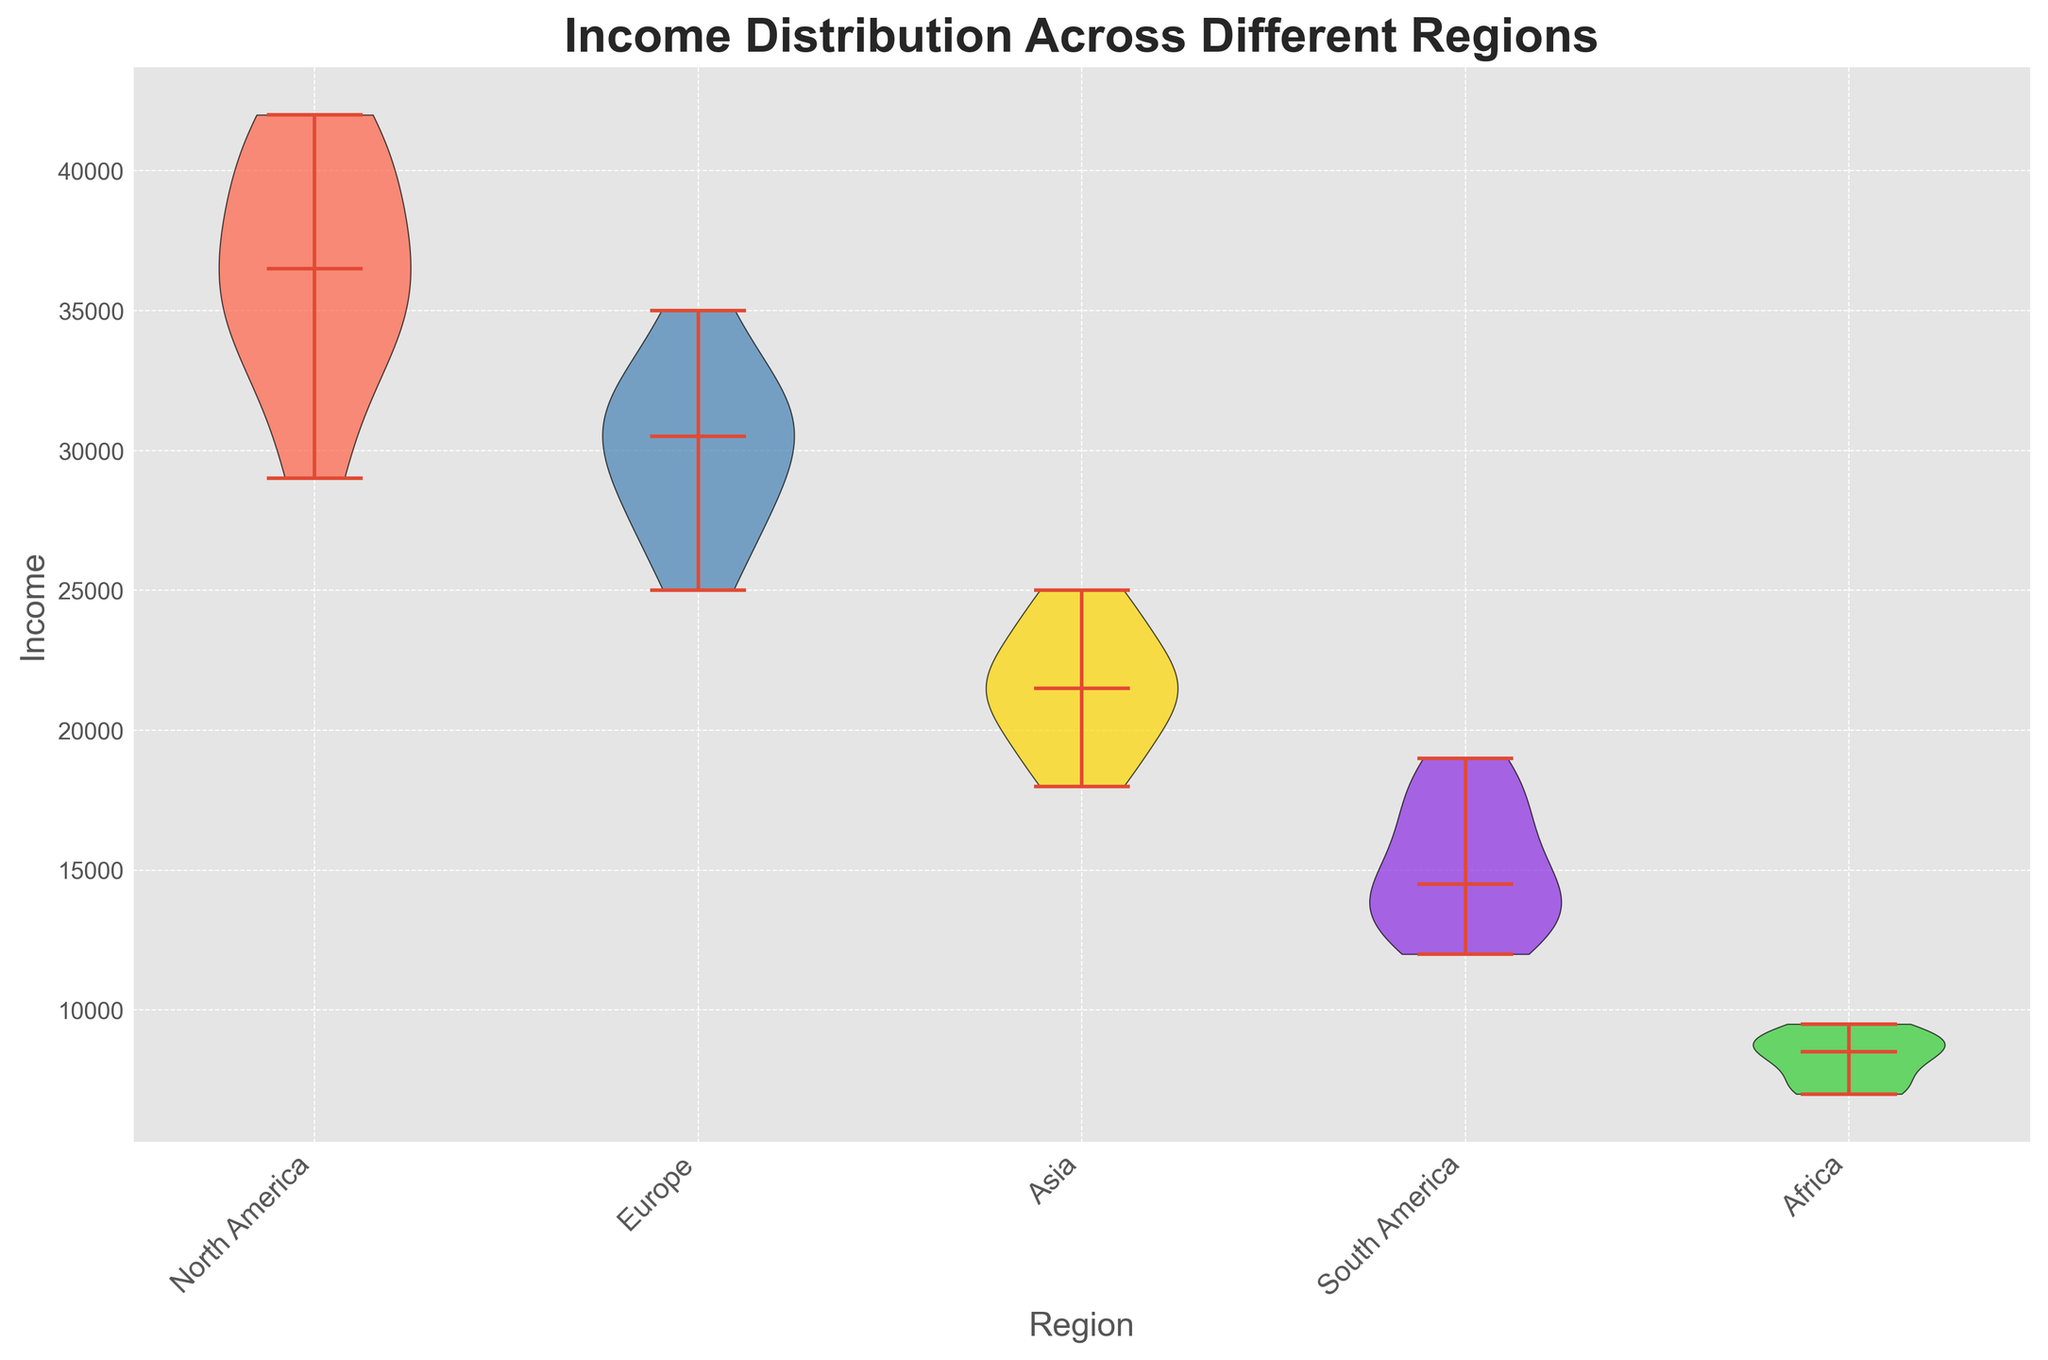Which region shows the highest median income? By looking at the central white dot in each violin plot, we can observe that North America has the highest median income compared to other regions.
Answer: North America Which region has the most diverse income distribution? The width of the violins indicates the spread of the income distribution. North America's violin plot is the widest, suggesting the greatest diversity in income distribution.
Answer: North America How does the median income in Europe compare to that in Asia? By comparing the central white dots of Europe and Asia, we can see that Europe has a higher median income than Asia.
Answer: Europe has a higher median income Which regions have overlapping income distributions? By observing the overlapping portions of the violins, we can see that Europe and North America's income distributions overlap. Similarly, Asia and South America's distributions overlap as well.
Answer: Europe and North America; Asia and South America What is the general range of income in Africa? The tips of the violin plot for Africa show the range of income, extending from about 7000 to 9500.
Answer: 7000 to 9500 Which region has the narrowest income distribution? By comparing the width of the violins, Africa has the narrowest distribution, indicating the least variability in income.
Answer: Africa Compare the median income between Europe and South America. Which one is higher and by how much? By observing the central white dots, Europe’s median income is higher than South America. To quantify, estimate Europe’s median around 31000 and South America's around 14000. Thus, Europe’s median income is higher by approximately 17000.
Answer: Europe by approximately 17000 In terms of visual lengths, which region has the highest income variability? North America’s violin plot spans the greatest vertical distance, indicating the highest variability in income.
Answer: North America Which region shows a median income of roughly 30000? By identifying the central white dots’ approximate positions, Europe shows a median income of roughly 30000.
Answer: Europe What can be said about the relative positions of North America and Asia in terms of income distribution? By analyzing the height and range of the violin plots, North America’s incomes are generally higher than those of Asia, with the former having a higher median and broader distribution range.
Answer: North America's income distribution is higher 